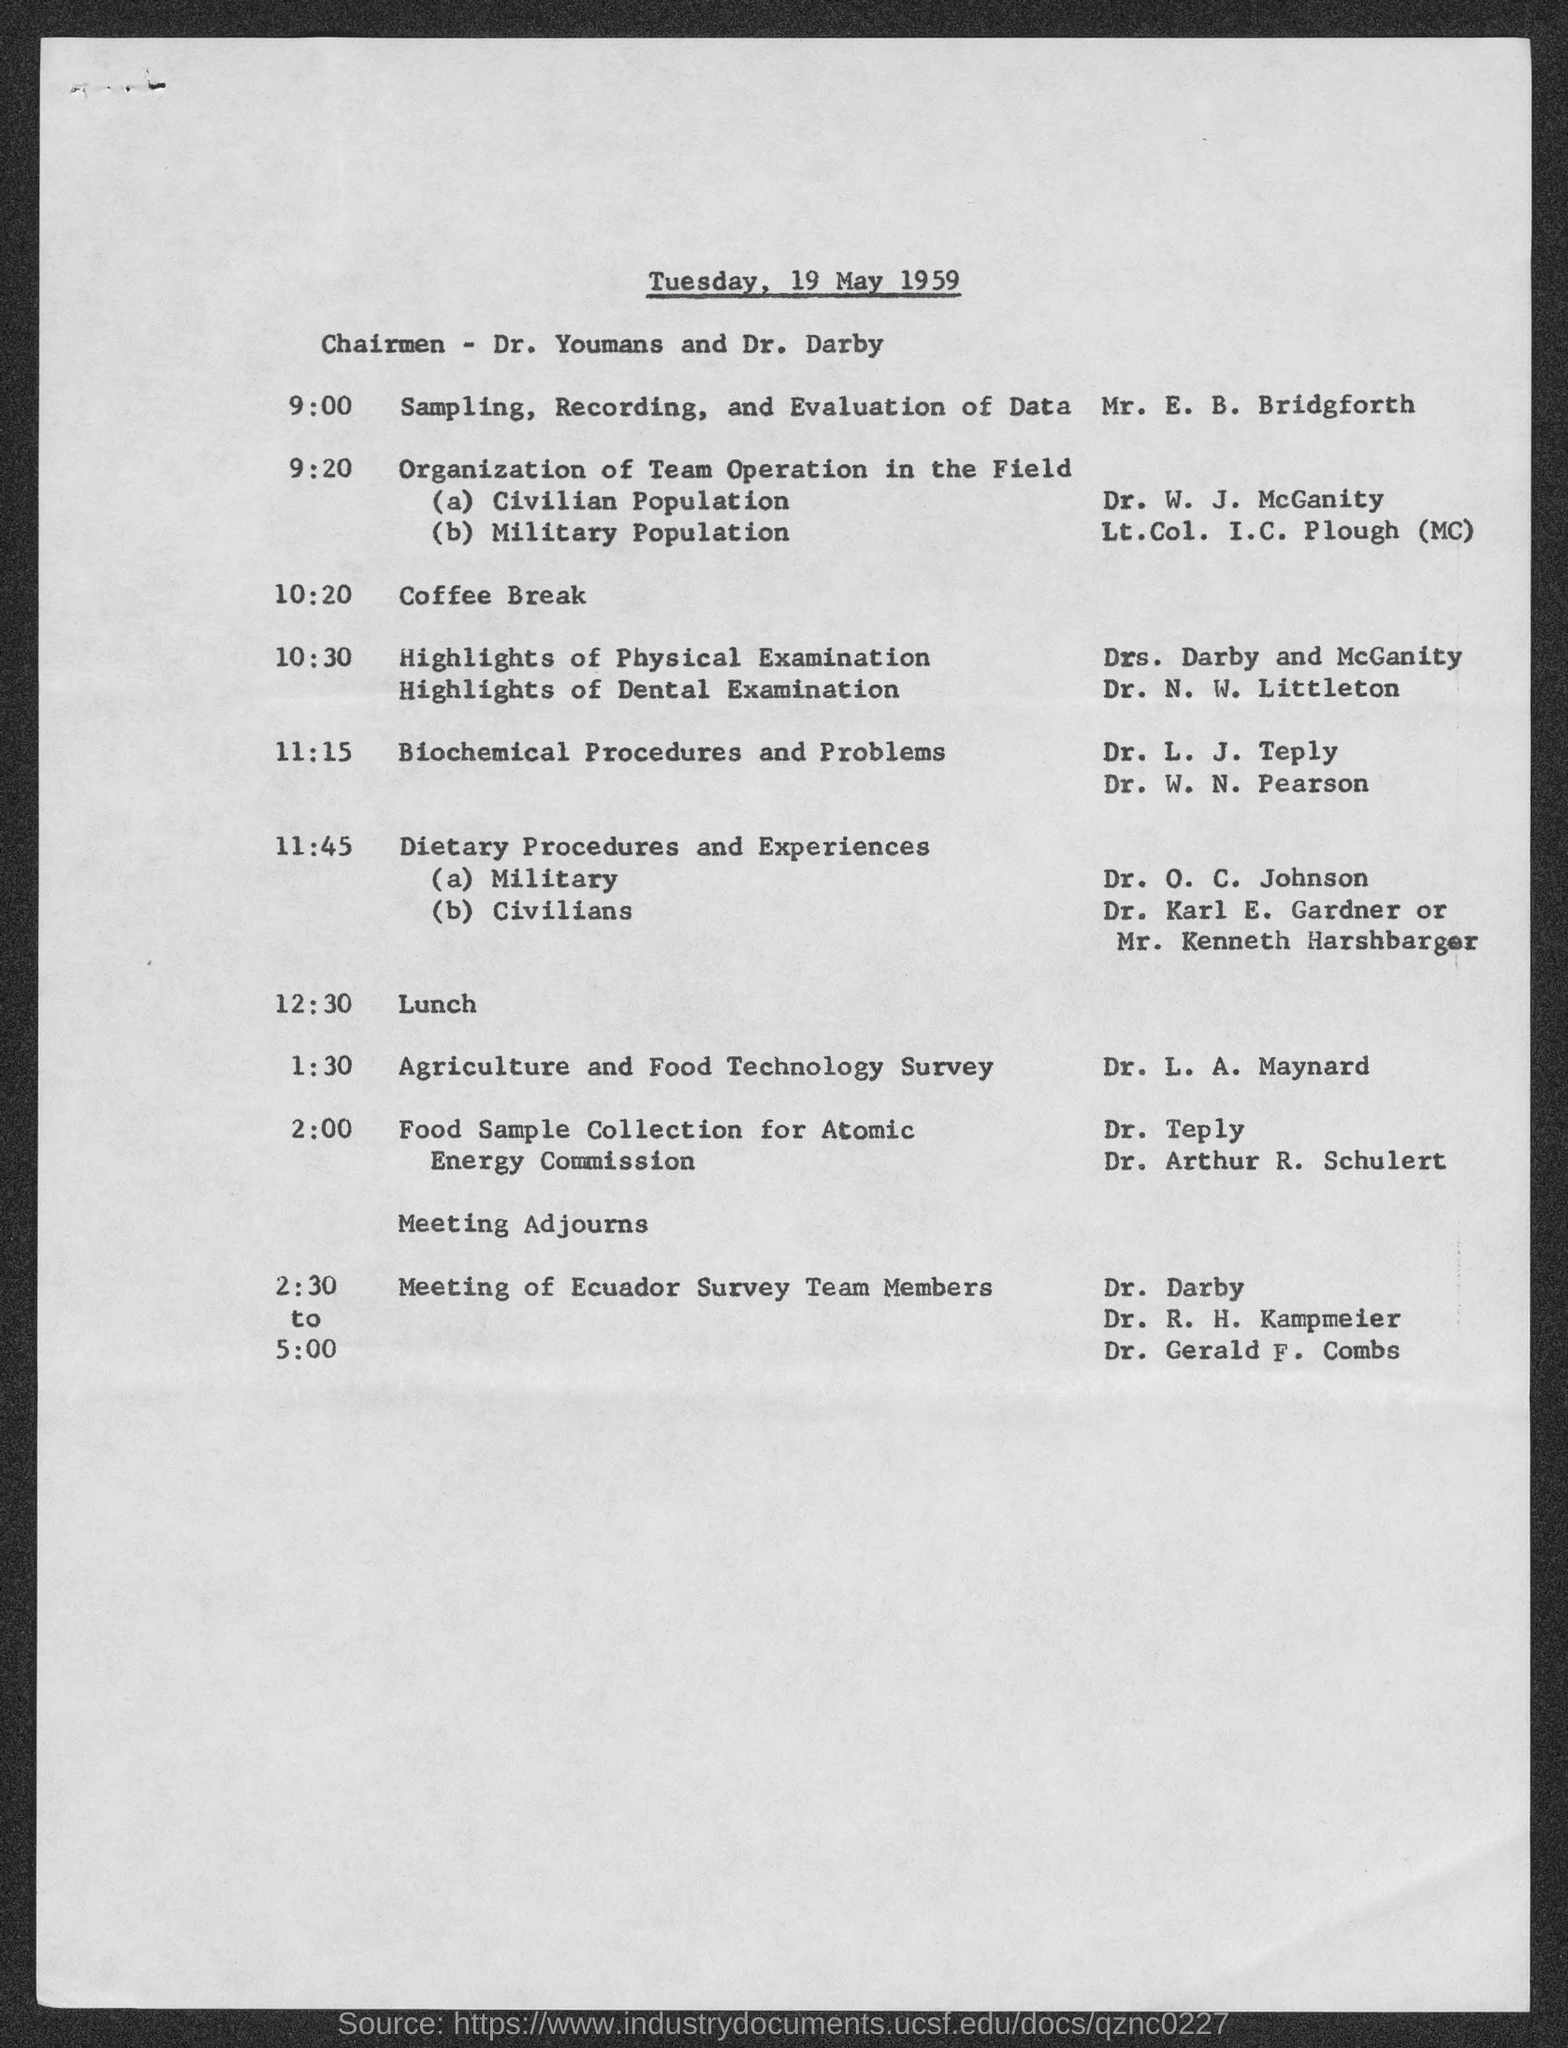Identify some key points in this picture. The meeting was concluded at 5:00 The Agriculture and Food Technology Survey was the subject of discussion during a meeting that began at 1:30 PM. Sampling, recording, and evaluation of data was performed by Mr. E. B. Bridgforth. On Tuesday, May 19, 1959, this meeting was organized. It is currently 12:30 PM and time for lunch. 